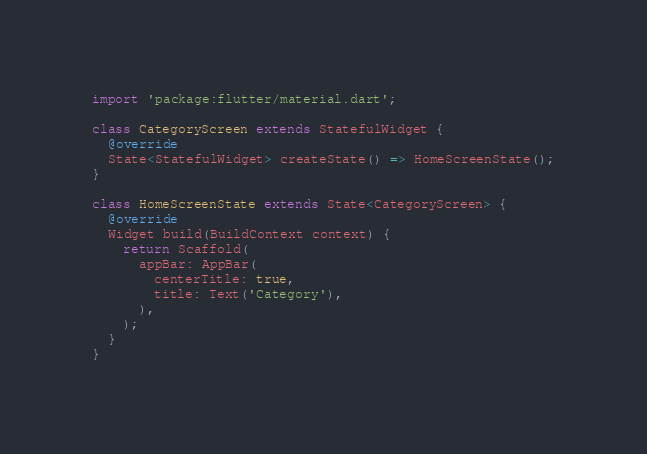Convert code to text. <code><loc_0><loc_0><loc_500><loc_500><_Dart_>

import 'package:flutter/material.dart';

class CategoryScreen extends StatefulWidget {
  @override
  State<StatefulWidget> createState() => HomeScreenState();
}

class HomeScreenState extends State<CategoryScreen> {
  @override
  Widget build(BuildContext context) {
    return Scaffold(
      appBar: AppBar(
        centerTitle: true,
        title: Text('Category'),
      ),
    );
  }
}
</code> 